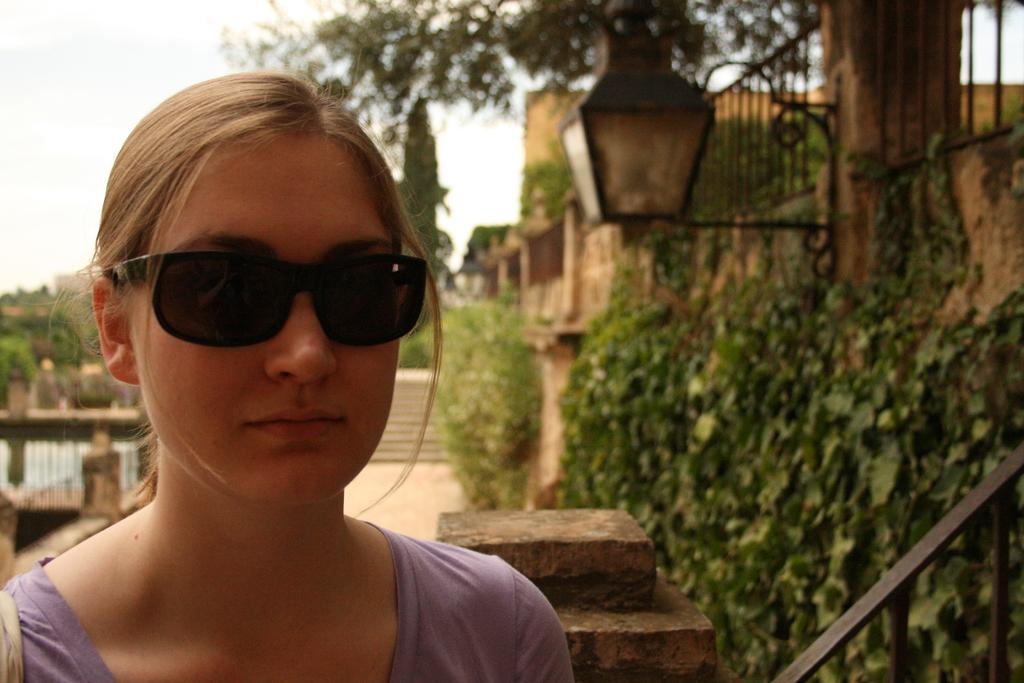Who is present in the image? There is a woman in the image. What is the woman wearing on her eyes? The woman is wearing goggles on her eyes. What can be seen in the background of the image? There are railings, plants, a light on the wall, steps, buildings, and the sky visible in the background of the image. Where is the lake located in the image? There is no lake present in the image. What type of prose is the woman reading in the image? There is no indication that the woman is reading any prose in the image. 